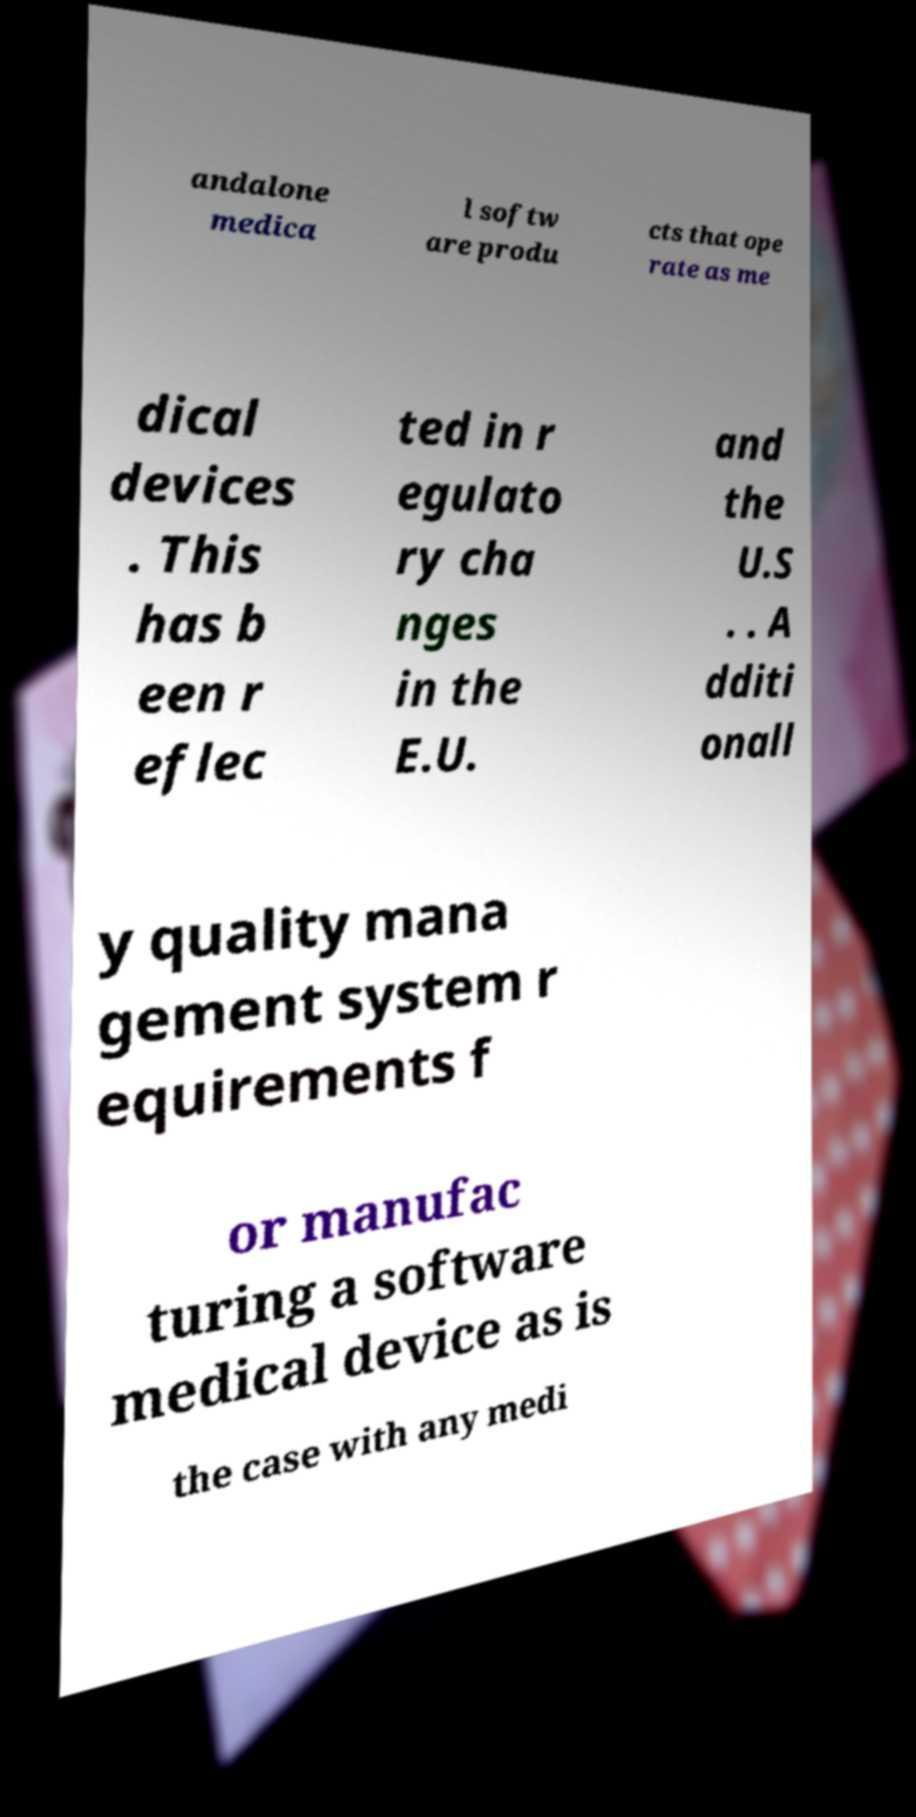Can you accurately transcribe the text from the provided image for me? andalone medica l softw are produ cts that ope rate as me dical devices . This has b een r eflec ted in r egulato ry cha nges in the E.U. and the U.S . . A dditi onall y quality mana gement system r equirements f or manufac turing a software medical device as is the case with any medi 